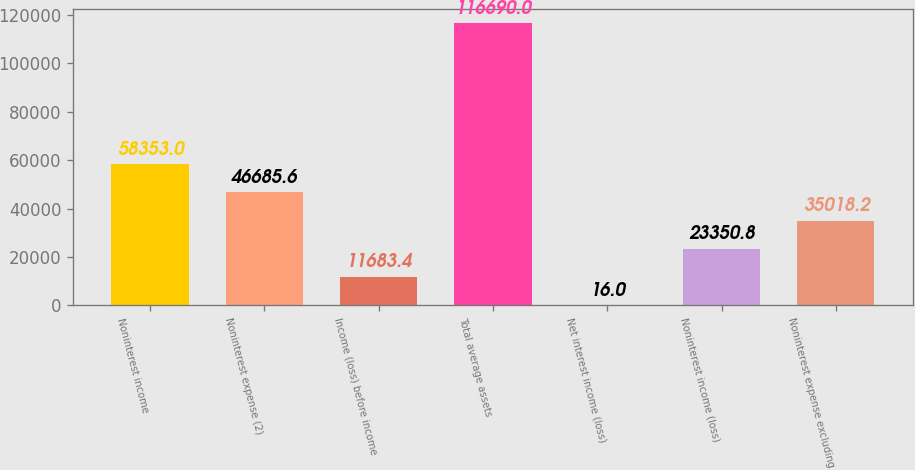<chart> <loc_0><loc_0><loc_500><loc_500><bar_chart><fcel>Noninterest income<fcel>Noninterest expense (2)<fcel>Income (loss) before income<fcel>Total average assets<fcel>Net interest income (loss)<fcel>Noninterest income (loss)<fcel>Noninterest expense excluding<nl><fcel>58353<fcel>46685.6<fcel>11683.4<fcel>116690<fcel>16<fcel>23350.8<fcel>35018.2<nl></chart> 